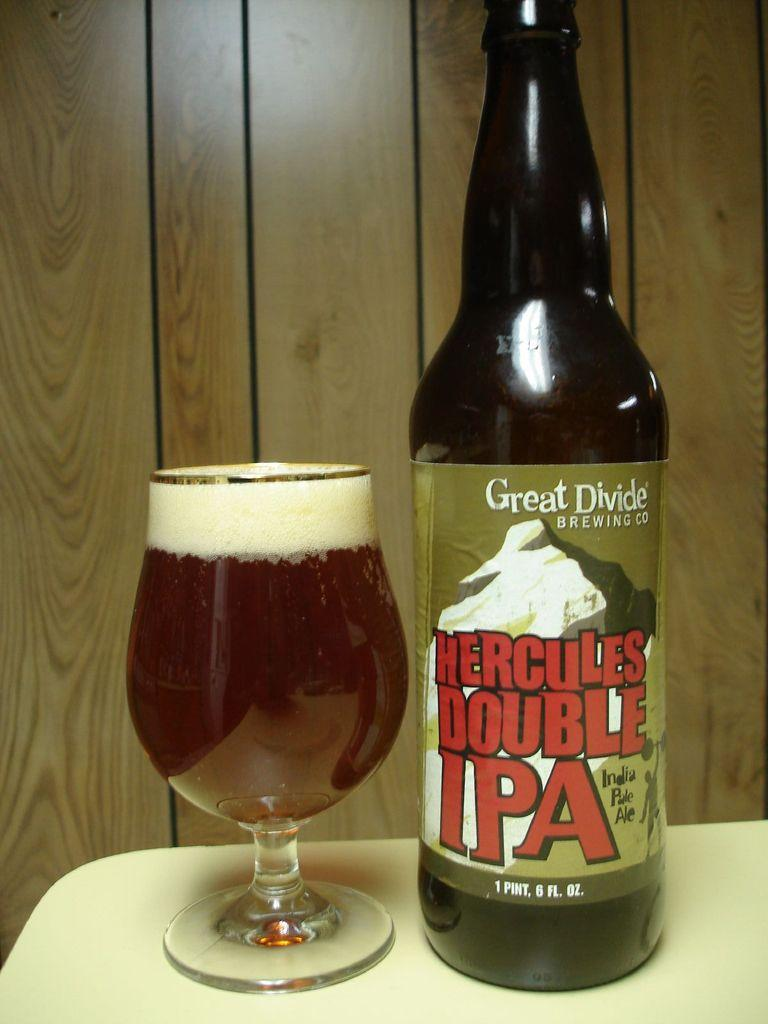<image>
Describe the image concisely. Hercules Double IPA beer bottle next to a cup of beer. 